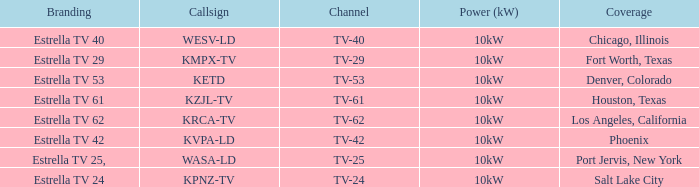List the power output for Phoenix.  10kW. 